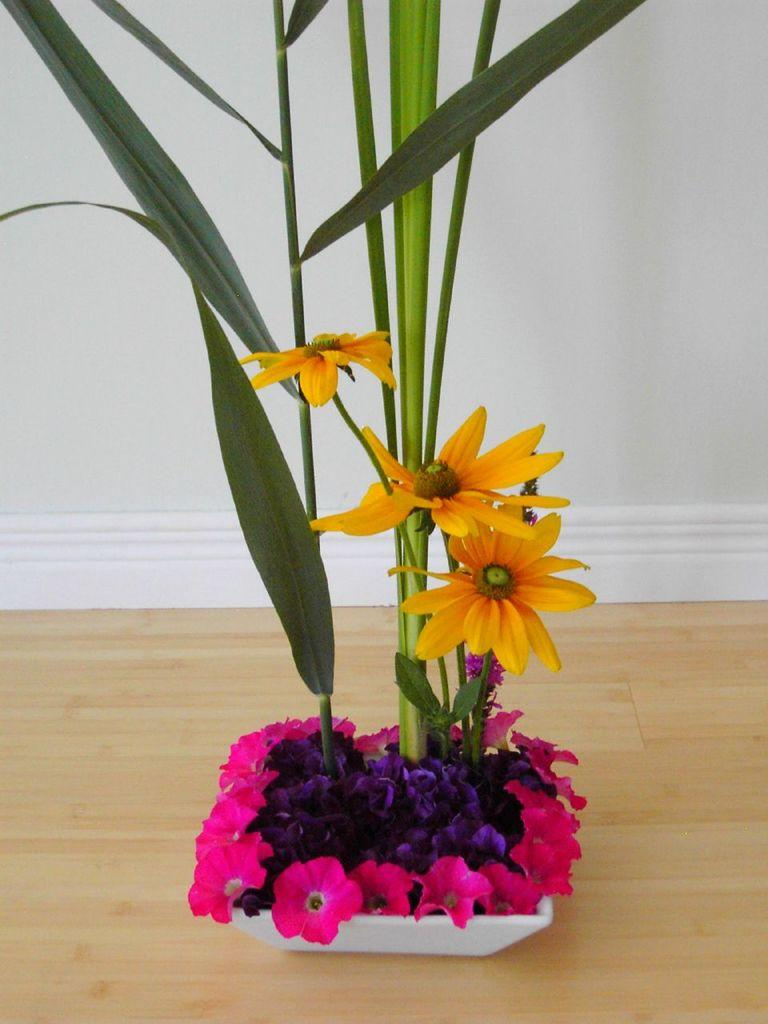What is the main subject of the image? The main subject of the image is a flower. Where is the flower located? The flower is in a pot. What is the color of the flower? The flower is white in color. Is there a veil covering the flower in the image? No, there is no veil present in the image. Can you tell me the chances of a doctor visiting the flower in the image? There is no information about a doctor or any visit in the image, so it's not possible to determine the chances of a doctor visiting the flower. 